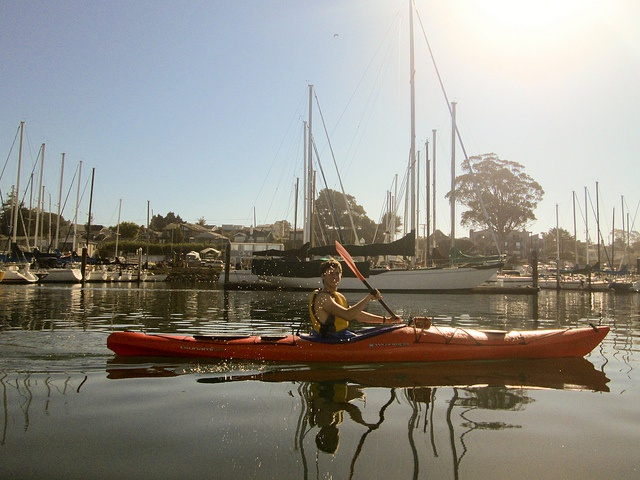Describe the objects in this image and their specific colors. I can see boat in gray, maroon, black, and ivory tones, boat in gray, black, and darkgray tones, people in gray, maroon, and black tones, boat in gray, black, and tan tones, and boat in gray and black tones in this image. 